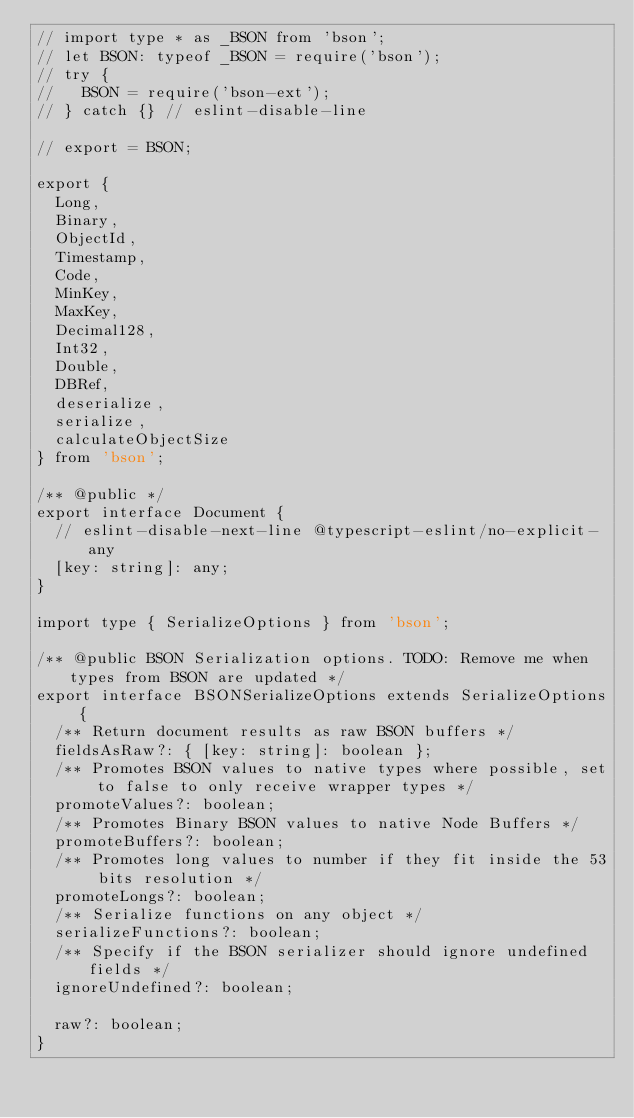Convert code to text. <code><loc_0><loc_0><loc_500><loc_500><_TypeScript_>// import type * as _BSON from 'bson';
// let BSON: typeof _BSON = require('bson');
// try {
//   BSON = require('bson-ext');
// } catch {} // eslint-disable-line

// export = BSON;

export {
  Long,
  Binary,
  ObjectId,
  Timestamp,
  Code,
  MinKey,
  MaxKey,
  Decimal128,
  Int32,
  Double,
  DBRef,
  deserialize,
  serialize,
  calculateObjectSize
} from 'bson';

/** @public */
export interface Document {
  // eslint-disable-next-line @typescript-eslint/no-explicit-any
  [key: string]: any;
}

import type { SerializeOptions } from 'bson';

/** @public BSON Serialization options. TODO: Remove me when types from BSON are updated */
export interface BSONSerializeOptions extends SerializeOptions {
  /** Return document results as raw BSON buffers */
  fieldsAsRaw?: { [key: string]: boolean };
  /** Promotes BSON values to native types where possible, set to false to only receive wrapper types */
  promoteValues?: boolean;
  /** Promotes Binary BSON values to native Node Buffers */
  promoteBuffers?: boolean;
  /** Promotes long values to number if they fit inside the 53 bits resolution */
  promoteLongs?: boolean;
  /** Serialize functions on any object */
  serializeFunctions?: boolean;
  /** Specify if the BSON serializer should ignore undefined fields */
  ignoreUndefined?: boolean;

  raw?: boolean;
}
</code> 